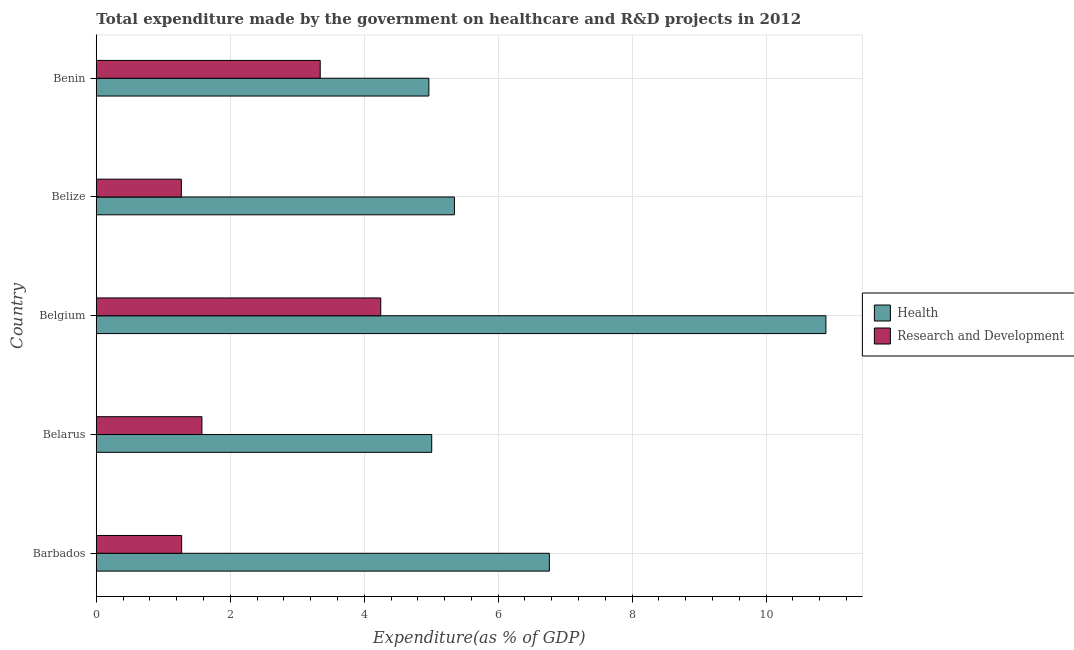How many different coloured bars are there?
Keep it short and to the point. 2. Are the number of bars per tick equal to the number of legend labels?
Your answer should be very brief. Yes. How many bars are there on the 1st tick from the bottom?
Your answer should be very brief. 2. What is the label of the 3rd group of bars from the top?
Provide a succinct answer. Belgium. What is the expenditure in r&d in Belgium?
Offer a very short reply. 4.25. Across all countries, what is the maximum expenditure in healthcare?
Make the answer very short. 10.89. Across all countries, what is the minimum expenditure in r&d?
Offer a terse response. 1.27. In which country was the expenditure in r&d minimum?
Provide a short and direct response. Belize. What is the total expenditure in r&d in the graph?
Provide a succinct answer. 11.71. What is the difference between the expenditure in r&d in Belize and that in Benin?
Provide a short and direct response. -2.07. What is the difference between the expenditure in r&d in Benin and the expenditure in healthcare in Belgium?
Offer a terse response. -7.55. What is the average expenditure in healthcare per country?
Your answer should be compact. 6.6. What is the difference between the expenditure in r&d and expenditure in healthcare in Belize?
Provide a short and direct response. -4.08. In how many countries, is the expenditure in r&d greater than 4 %?
Provide a short and direct response. 1. What is the ratio of the expenditure in r&d in Barbados to that in Belgium?
Your answer should be compact. 0.3. Is the expenditure in healthcare in Barbados less than that in Belarus?
Provide a succinct answer. No. What is the difference between the highest and the second highest expenditure in healthcare?
Give a very brief answer. 4.13. What is the difference between the highest and the lowest expenditure in healthcare?
Give a very brief answer. 5.93. Is the sum of the expenditure in r&d in Belize and Benin greater than the maximum expenditure in healthcare across all countries?
Your response must be concise. No. What does the 2nd bar from the top in Belarus represents?
Your answer should be very brief. Health. What does the 2nd bar from the bottom in Belarus represents?
Provide a succinct answer. Research and Development. How many bars are there?
Make the answer very short. 10. Are all the bars in the graph horizontal?
Make the answer very short. Yes. Does the graph contain any zero values?
Your answer should be compact. No. How many legend labels are there?
Offer a terse response. 2. How are the legend labels stacked?
Provide a short and direct response. Vertical. What is the title of the graph?
Offer a terse response. Total expenditure made by the government on healthcare and R&D projects in 2012. Does "From human activities" appear as one of the legend labels in the graph?
Your answer should be very brief. No. What is the label or title of the X-axis?
Ensure brevity in your answer.  Expenditure(as % of GDP). What is the label or title of the Y-axis?
Give a very brief answer. Country. What is the Expenditure(as % of GDP) of Health in Barbados?
Give a very brief answer. 6.76. What is the Expenditure(as % of GDP) in Research and Development in Barbados?
Make the answer very short. 1.27. What is the Expenditure(as % of GDP) in Health in Belarus?
Provide a short and direct response. 5.01. What is the Expenditure(as % of GDP) of Research and Development in Belarus?
Keep it short and to the point. 1.58. What is the Expenditure(as % of GDP) of Health in Belgium?
Provide a short and direct response. 10.89. What is the Expenditure(as % of GDP) of Research and Development in Belgium?
Give a very brief answer. 4.25. What is the Expenditure(as % of GDP) in Health in Belize?
Your answer should be very brief. 5.35. What is the Expenditure(as % of GDP) of Research and Development in Belize?
Provide a short and direct response. 1.27. What is the Expenditure(as % of GDP) in Health in Benin?
Provide a short and direct response. 4.97. What is the Expenditure(as % of GDP) in Research and Development in Benin?
Ensure brevity in your answer.  3.34. Across all countries, what is the maximum Expenditure(as % of GDP) of Health?
Make the answer very short. 10.89. Across all countries, what is the maximum Expenditure(as % of GDP) of Research and Development?
Ensure brevity in your answer.  4.25. Across all countries, what is the minimum Expenditure(as % of GDP) of Health?
Give a very brief answer. 4.97. Across all countries, what is the minimum Expenditure(as % of GDP) of Research and Development?
Offer a very short reply. 1.27. What is the total Expenditure(as % of GDP) of Health in the graph?
Offer a terse response. 32.98. What is the total Expenditure(as % of GDP) of Research and Development in the graph?
Offer a very short reply. 11.71. What is the difference between the Expenditure(as % of GDP) of Health in Barbados and that in Belarus?
Your response must be concise. 1.76. What is the difference between the Expenditure(as % of GDP) in Research and Development in Barbados and that in Belarus?
Your answer should be very brief. -0.3. What is the difference between the Expenditure(as % of GDP) of Health in Barbados and that in Belgium?
Your answer should be compact. -4.13. What is the difference between the Expenditure(as % of GDP) in Research and Development in Barbados and that in Belgium?
Provide a succinct answer. -2.97. What is the difference between the Expenditure(as % of GDP) of Health in Barbados and that in Belize?
Ensure brevity in your answer.  1.42. What is the difference between the Expenditure(as % of GDP) in Research and Development in Barbados and that in Belize?
Make the answer very short. 0. What is the difference between the Expenditure(as % of GDP) of Health in Barbados and that in Benin?
Your answer should be compact. 1.8. What is the difference between the Expenditure(as % of GDP) of Research and Development in Barbados and that in Benin?
Provide a succinct answer. -2.07. What is the difference between the Expenditure(as % of GDP) in Health in Belarus and that in Belgium?
Provide a short and direct response. -5.89. What is the difference between the Expenditure(as % of GDP) in Research and Development in Belarus and that in Belgium?
Give a very brief answer. -2.67. What is the difference between the Expenditure(as % of GDP) of Health in Belarus and that in Belize?
Ensure brevity in your answer.  -0.34. What is the difference between the Expenditure(as % of GDP) in Research and Development in Belarus and that in Belize?
Ensure brevity in your answer.  0.31. What is the difference between the Expenditure(as % of GDP) of Health in Belarus and that in Benin?
Make the answer very short. 0.04. What is the difference between the Expenditure(as % of GDP) of Research and Development in Belarus and that in Benin?
Provide a succinct answer. -1.77. What is the difference between the Expenditure(as % of GDP) in Health in Belgium and that in Belize?
Make the answer very short. 5.55. What is the difference between the Expenditure(as % of GDP) of Research and Development in Belgium and that in Belize?
Give a very brief answer. 2.98. What is the difference between the Expenditure(as % of GDP) in Health in Belgium and that in Benin?
Provide a short and direct response. 5.93. What is the difference between the Expenditure(as % of GDP) of Research and Development in Belgium and that in Benin?
Your answer should be very brief. 0.9. What is the difference between the Expenditure(as % of GDP) of Health in Belize and that in Benin?
Provide a short and direct response. 0.38. What is the difference between the Expenditure(as % of GDP) in Research and Development in Belize and that in Benin?
Provide a short and direct response. -2.07. What is the difference between the Expenditure(as % of GDP) in Health in Barbados and the Expenditure(as % of GDP) in Research and Development in Belarus?
Make the answer very short. 5.19. What is the difference between the Expenditure(as % of GDP) of Health in Barbados and the Expenditure(as % of GDP) of Research and Development in Belgium?
Offer a very short reply. 2.52. What is the difference between the Expenditure(as % of GDP) of Health in Barbados and the Expenditure(as % of GDP) of Research and Development in Belize?
Provide a succinct answer. 5.5. What is the difference between the Expenditure(as % of GDP) of Health in Barbados and the Expenditure(as % of GDP) of Research and Development in Benin?
Ensure brevity in your answer.  3.42. What is the difference between the Expenditure(as % of GDP) in Health in Belarus and the Expenditure(as % of GDP) in Research and Development in Belgium?
Your answer should be compact. 0.76. What is the difference between the Expenditure(as % of GDP) of Health in Belarus and the Expenditure(as % of GDP) of Research and Development in Belize?
Make the answer very short. 3.74. What is the difference between the Expenditure(as % of GDP) in Health in Belarus and the Expenditure(as % of GDP) in Research and Development in Benin?
Provide a short and direct response. 1.67. What is the difference between the Expenditure(as % of GDP) of Health in Belgium and the Expenditure(as % of GDP) of Research and Development in Belize?
Your answer should be compact. 9.62. What is the difference between the Expenditure(as % of GDP) of Health in Belgium and the Expenditure(as % of GDP) of Research and Development in Benin?
Keep it short and to the point. 7.55. What is the difference between the Expenditure(as % of GDP) in Health in Belize and the Expenditure(as % of GDP) in Research and Development in Benin?
Your answer should be very brief. 2. What is the average Expenditure(as % of GDP) in Health per country?
Ensure brevity in your answer.  6.6. What is the average Expenditure(as % of GDP) in Research and Development per country?
Make the answer very short. 2.34. What is the difference between the Expenditure(as % of GDP) in Health and Expenditure(as % of GDP) in Research and Development in Barbados?
Your answer should be very brief. 5.49. What is the difference between the Expenditure(as % of GDP) of Health and Expenditure(as % of GDP) of Research and Development in Belarus?
Offer a very short reply. 3.43. What is the difference between the Expenditure(as % of GDP) of Health and Expenditure(as % of GDP) of Research and Development in Belgium?
Provide a short and direct response. 6.65. What is the difference between the Expenditure(as % of GDP) of Health and Expenditure(as % of GDP) of Research and Development in Belize?
Keep it short and to the point. 4.08. What is the difference between the Expenditure(as % of GDP) of Health and Expenditure(as % of GDP) of Research and Development in Benin?
Ensure brevity in your answer.  1.62. What is the ratio of the Expenditure(as % of GDP) in Health in Barbados to that in Belarus?
Ensure brevity in your answer.  1.35. What is the ratio of the Expenditure(as % of GDP) of Research and Development in Barbados to that in Belarus?
Your response must be concise. 0.81. What is the ratio of the Expenditure(as % of GDP) of Health in Barbados to that in Belgium?
Your response must be concise. 0.62. What is the ratio of the Expenditure(as % of GDP) of Research and Development in Barbados to that in Belgium?
Make the answer very short. 0.3. What is the ratio of the Expenditure(as % of GDP) in Health in Barbados to that in Belize?
Your response must be concise. 1.27. What is the ratio of the Expenditure(as % of GDP) of Health in Barbados to that in Benin?
Give a very brief answer. 1.36. What is the ratio of the Expenditure(as % of GDP) of Research and Development in Barbados to that in Benin?
Offer a terse response. 0.38. What is the ratio of the Expenditure(as % of GDP) of Health in Belarus to that in Belgium?
Your answer should be very brief. 0.46. What is the ratio of the Expenditure(as % of GDP) of Research and Development in Belarus to that in Belgium?
Offer a very short reply. 0.37. What is the ratio of the Expenditure(as % of GDP) in Health in Belarus to that in Belize?
Ensure brevity in your answer.  0.94. What is the ratio of the Expenditure(as % of GDP) in Research and Development in Belarus to that in Belize?
Offer a terse response. 1.24. What is the ratio of the Expenditure(as % of GDP) of Health in Belarus to that in Benin?
Make the answer very short. 1.01. What is the ratio of the Expenditure(as % of GDP) of Research and Development in Belarus to that in Benin?
Give a very brief answer. 0.47. What is the ratio of the Expenditure(as % of GDP) of Health in Belgium to that in Belize?
Make the answer very short. 2.04. What is the ratio of the Expenditure(as % of GDP) of Research and Development in Belgium to that in Belize?
Offer a very short reply. 3.35. What is the ratio of the Expenditure(as % of GDP) of Health in Belgium to that in Benin?
Ensure brevity in your answer.  2.19. What is the ratio of the Expenditure(as % of GDP) in Research and Development in Belgium to that in Benin?
Provide a succinct answer. 1.27. What is the ratio of the Expenditure(as % of GDP) of Health in Belize to that in Benin?
Provide a succinct answer. 1.08. What is the ratio of the Expenditure(as % of GDP) in Research and Development in Belize to that in Benin?
Keep it short and to the point. 0.38. What is the difference between the highest and the second highest Expenditure(as % of GDP) in Health?
Offer a very short reply. 4.13. What is the difference between the highest and the second highest Expenditure(as % of GDP) of Research and Development?
Your answer should be very brief. 0.9. What is the difference between the highest and the lowest Expenditure(as % of GDP) in Health?
Offer a very short reply. 5.93. What is the difference between the highest and the lowest Expenditure(as % of GDP) of Research and Development?
Make the answer very short. 2.98. 